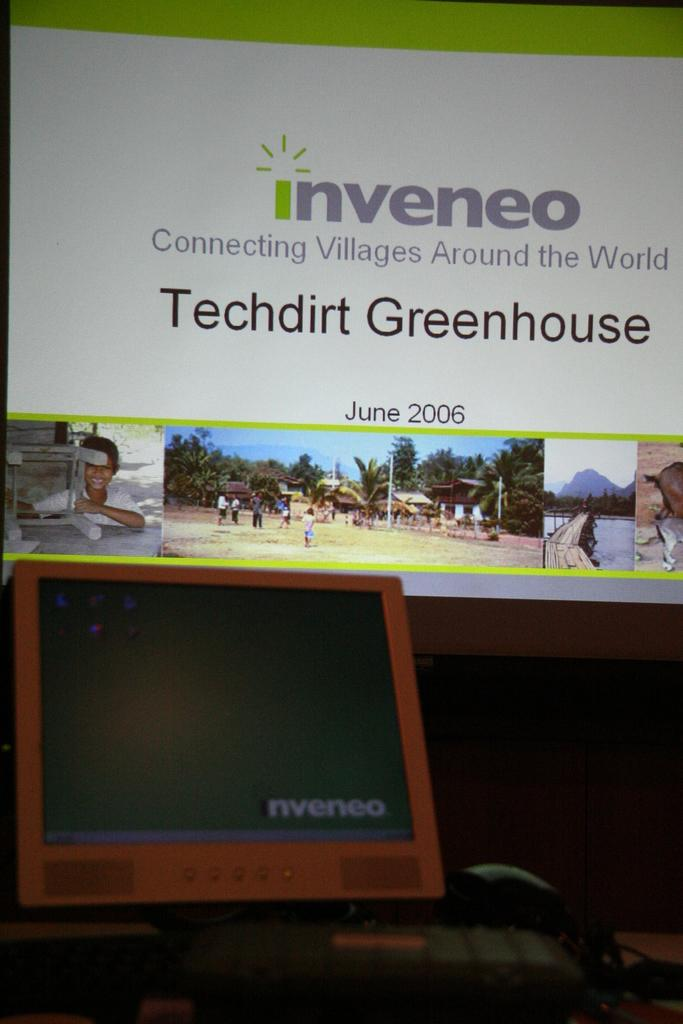<image>
Render a clear and concise summary of the photo. An Inveneo banner hangs above a red inveneo computer 